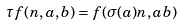Convert formula to latex. <formula><loc_0><loc_0><loc_500><loc_500>\tau f ( n , a , b ) = f ( \sigma ( a ) n , a b )</formula> 